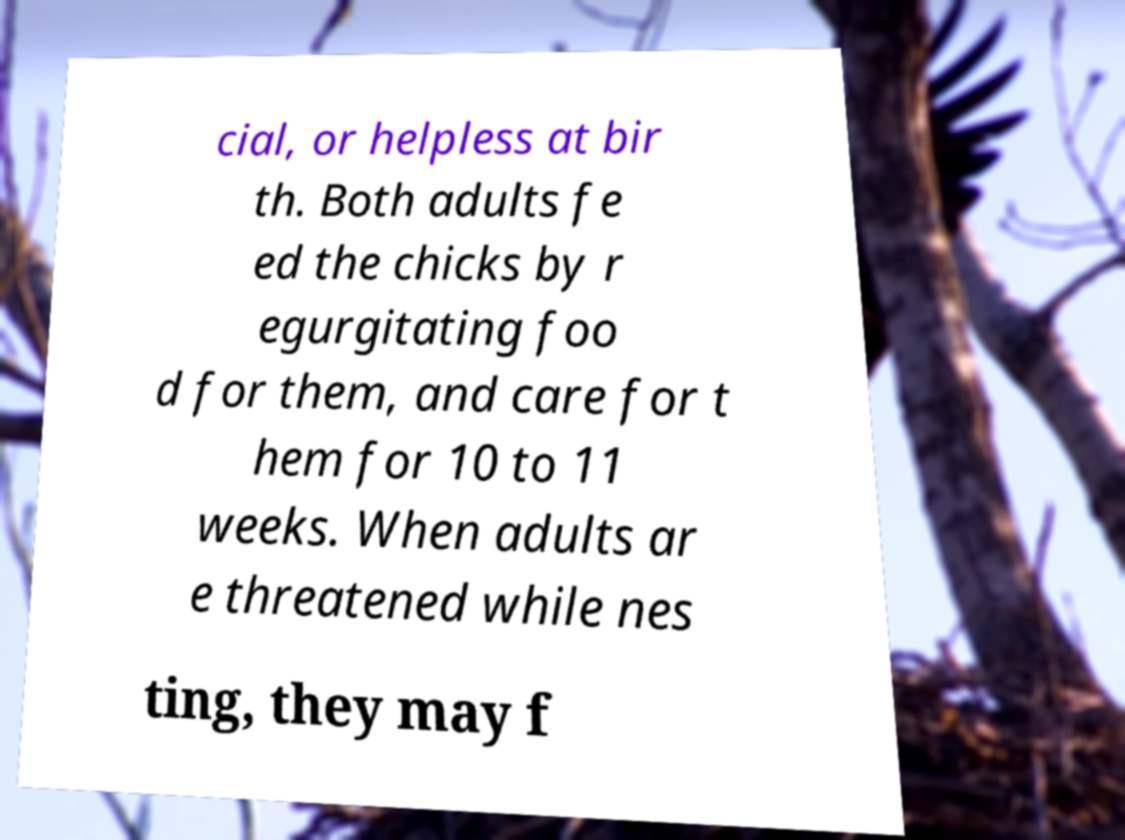There's text embedded in this image that I need extracted. Can you transcribe it verbatim? cial, or helpless at bir th. Both adults fe ed the chicks by r egurgitating foo d for them, and care for t hem for 10 to 11 weeks. When adults ar e threatened while nes ting, they may f 